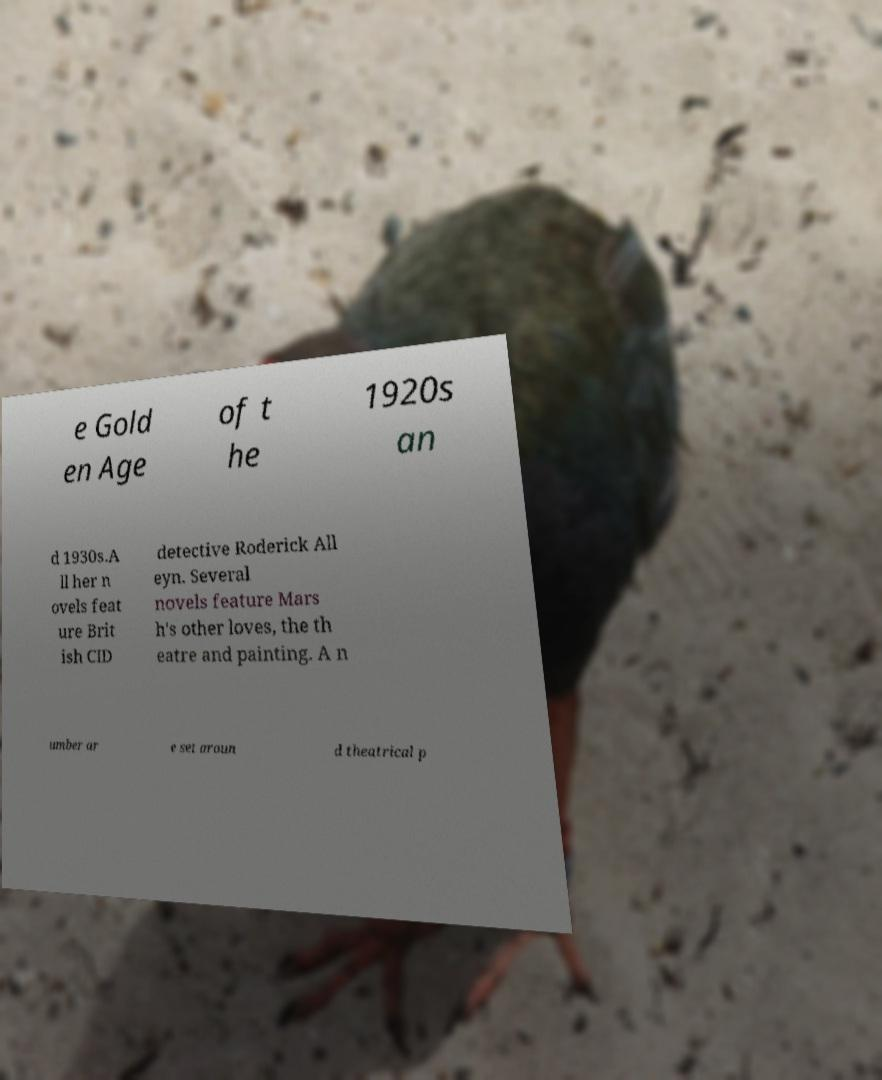Please identify and transcribe the text found in this image. e Gold en Age of t he 1920s an d 1930s.A ll her n ovels feat ure Brit ish CID detective Roderick All eyn. Several novels feature Mars h's other loves, the th eatre and painting. A n umber ar e set aroun d theatrical p 